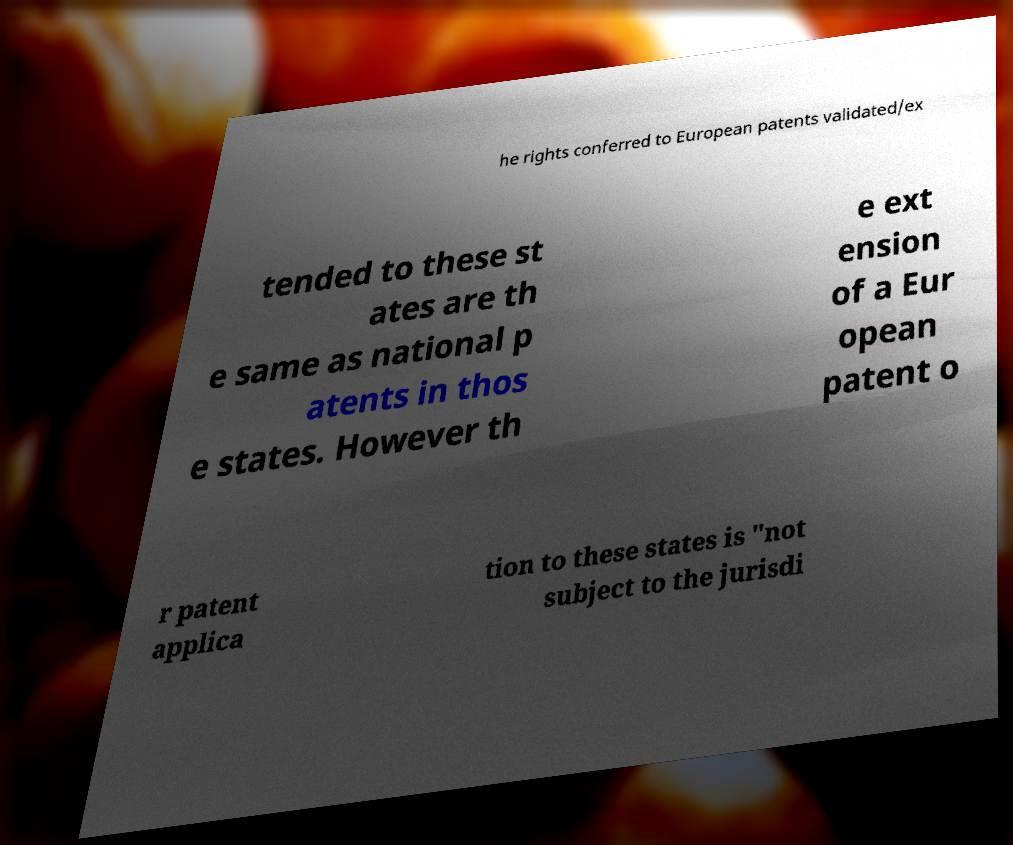Can you accurately transcribe the text from the provided image for me? he rights conferred to European patents validated/ex tended to these st ates are th e same as national p atents in thos e states. However th e ext ension of a Eur opean patent o r patent applica tion to these states is "not subject to the jurisdi 